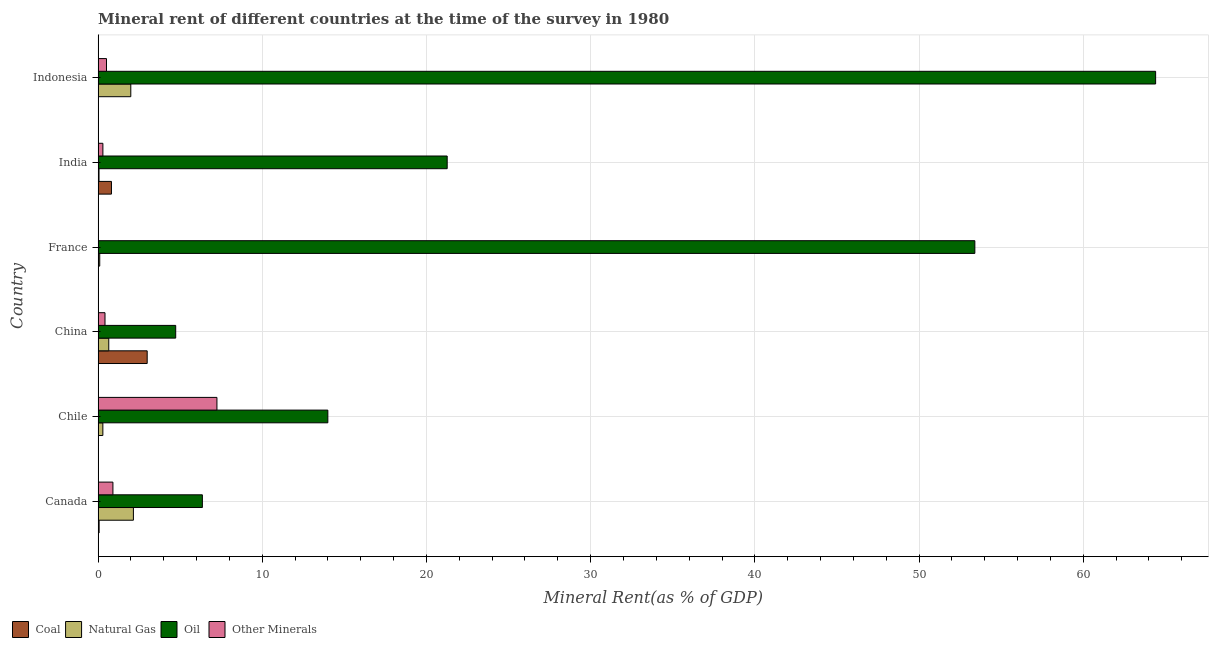How many different coloured bars are there?
Your answer should be very brief. 4. Are the number of bars per tick equal to the number of legend labels?
Offer a very short reply. Yes. Are the number of bars on each tick of the Y-axis equal?
Provide a short and direct response. Yes. What is the label of the 3rd group of bars from the top?
Give a very brief answer. France. In how many cases, is the number of bars for a given country not equal to the number of legend labels?
Your response must be concise. 0. What is the oil rent in Indonesia?
Your answer should be compact. 64.41. Across all countries, what is the maximum  rent of other minerals?
Your answer should be compact. 7.24. Across all countries, what is the minimum oil rent?
Offer a terse response. 4.73. In which country was the oil rent maximum?
Keep it short and to the point. Indonesia. What is the total coal rent in the graph?
Give a very brief answer. 3.89. What is the difference between the coal rent in France and that in Indonesia?
Provide a succinct answer. 0.01. What is the difference between the oil rent in China and the  rent of other minerals in Chile?
Offer a very short reply. -2.51. What is the average  rent of other minerals per country?
Offer a terse response. 1.56. What is the difference between the coal rent and  rent of other minerals in Indonesia?
Your answer should be very brief. -0.51. What is the ratio of the  rent of other minerals in China to that in France?
Your answer should be very brief. 27.3. Is the natural gas rent in Chile less than that in France?
Keep it short and to the point. No. What is the difference between the highest and the second highest oil rent?
Give a very brief answer. 11.01. What is the difference between the highest and the lowest  rent of other minerals?
Provide a short and direct response. 7.22. What does the 4th bar from the top in Indonesia represents?
Your response must be concise. Coal. What does the 3rd bar from the bottom in Canada represents?
Your answer should be very brief. Oil. Is it the case that in every country, the sum of the coal rent and natural gas rent is greater than the oil rent?
Make the answer very short. No. How many bars are there?
Keep it short and to the point. 24. Are all the bars in the graph horizontal?
Make the answer very short. Yes. How many countries are there in the graph?
Your answer should be compact. 6. Does the graph contain any zero values?
Your response must be concise. No. Does the graph contain grids?
Your response must be concise. Yes. How many legend labels are there?
Provide a short and direct response. 4. How are the legend labels stacked?
Your answer should be compact. Horizontal. What is the title of the graph?
Give a very brief answer. Mineral rent of different countries at the time of the survey in 1980. Does "Social Protection" appear as one of the legend labels in the graph?
Your answer should be very brief. No. What is the label or title of the X-axis?
Make the answer very short. Mineral Rent(as % of GDP). What is the label or title of the Y-axis?
Offer a terse response. Country. What is the Mineral Rent(as % of GDP) in Coal in Canada?
Offer a very short reply. 0.06. What is the Mineral Rent(as % of GDP) in Natural Gas in Canada?
Offer a terse response. 2.15. What is the Mineral Rent(as % of GDP) of Oil in Canada?
Your response must be concise. 6.35. What is the Mineral Rent(as % of GDP) of Other Minerals in Canada?
Offer a very short reply. 0.9. What is the Mineral Rent(as % of GDP) in Coal in Chile?
Provide a short and direct response. 0.02. What is the Mineral Rent(as % of GDP) of Natural Gas in Chile?
Offer a terse response. 0.29. What is the Mineral Rent(as % of GDP) in Oil in Chile?
Keep it short and to the point. 13.99. What is the Mineral Rent(as % of GDP) in Other Minerals in Chile?
Keep it short and to the point. 7.24. What is the Mineral Rent(as % of GDP) of Coal in China?
Ensure brevity in your answer.  2.99. What is the Mineral Rent(as % of GDP) in Natural Gas in China?
Your answer should be very brief. 0.65. What is the Mineral Rent(as % of GDP) of Oil in China?
Make the answer very short. 4.73. What is the Mineral Rent(as % of GDP) of Other Minerals in China?
Keep it short and to the point. 0.42. What is the Mineral Rent(as % of GDP) of Coal in France?
Your answer should be compact. 0.01. What is the Mineral Rent(as % of GDP) of Natural Gas in France?
Provide a succinct answer. 0.1. What is the Mineral Rent(as % of GDP) in Oil in France?
Offer a very short reply. 53.4. What is the Mineral Rent(as % of GDP) of Other Minerals in France?
Keep it short and to the point. 0.02. What is the Mineral Rent(as % of GDP) of Coal in India?
Provide a succinct answer. 0.81. What is the Mineral Rent(as % of GDP) of Natural Gas in India?
Your answer should be compact. 0.06. What is the Mineral Rent(as % of GDP) of Oil in India?
Offer a terse response. 21.26. What is the Mineral Rent(as % of GDP) of Other Minerals in India?
Provide a short and direct response. 0.29. What is the Mineral Rent(as % of GDP) in Coal in Indonesia?
Your answer should be very brief. 0. What is the Mineral Rent(as % of GDP) of Natural Gas in Indonesia?
Provide a short and direct response. 1.99. What is the Mineral Rent(as % of GDP) in Oil in Indonesia?
Make the answer very short. 64.41. What is the Mineral Rent(as % of GDP) in Other Minerals in Indonesia?
Keep it short and to the point. 0.51. Across all countries, what is the maximum Mineral Rent(as % of GDP) of Coal?
Your answer should be compact. 2.99. Across all countries, what is the maximum Mineral Rent(as % of GDP) in Natural Gas?
Your response must be concise. 2.15. Across all countries, what is the maximum Mineral Rent(as % of GDP) of Oil?
Your answer should be compact. 64.41. Across all countries, what is the maximum Mineral Rent(as % of GDP) in Other Minerals?
Ensure brevity in your answer.  7.24. Across all countries, what is the minimum Mineral Rent(as % of GDP) in Coal?
Provide a short and direct response. 0. Across all countries, what is the minimum Mineral Rent(as % of GDP) in Natural Gas?
Your answer should be compact. 0.06. Across all countries, what is the minimum Mineral Rent(as % of GDP) in Oil?
Your answer should be compact. 4.73. Across all countries, what is the minimum Mineral Rent(as % of GDP) in Other Minerals?
Provide a short and direct response. 0.02. What is the total Mineral Rent(as % of GDP) in Coal in the graph?
Keep it short and to the point. 3.89. What is the total Mineral Rent(as % of GDP) of Natural Gas in the graph?
Give a very brief answer. 5.23. What is the total Mineral Rent(as % of GDP) in Oil in the graph?
Provide a succinct answer. 164.14. What is the total Mineral Rent(as % of GDP) in Other Minerals in the graph?
Provide a short and direct response. 9.38. What is the difference between the Mineral Rent(as % of GDP) in Coal in Canada and that in Chile?
Your answer should be compact. 0.04. What is the difference between the Mineral Rent(as % of GDP) of Natural Gas in Canada and that in Chile?
Your answer should be very brief. 1.86. What is the difference between the Mineral Rent(as % of GDP) of Oil in Canada and that in Chile?
Offer a terse response. -7.64. What is the difference between the Mineral Rent(as % of GDP) in Other Minerals in Canada and that in Chile?
Your answer should be compact. -6.34. What is the difference between the Mineral Rent(as % of GDP) in Coal in Canada and that in China?
Ensure brevity in your answer.  -2.93. What is the difference between the Mineral Rent(as % of GDP) of Natural Gas in Canada and that in China?
Give a very brief answer. 1.5. What is the difference between the Mineral Rent(as % of GDP) in Oil in Canada and that in China?
Keep it short and to the point. 1.62. What is the difference between the Mineral Rent(as % of GDP) of Other Minerals in Canada and that in China?
Ensure brevity in your answer.  0.48. What is the difference between the Mineral Rent(as % of GDP) of Coal in Canada and that in France?
Keep it short and to the point. 0.05. What is the difference between the Mineral Rent(as % of GDP) in Natural Gas in Canada and that in France?
Provide a short and direct response. 2.05. What is the difference between the Mineral Rent(as % of GDP) of Oil in Canada and that in France?
Ensure brevity in your answer.  -47.05. What is the difference between the Mineral Rent(as % of GDP) of Other Minerals in Canada and that in France?
Offer a very short reply. 0.89. What is the difference between the Mineral Rent(as % of GDP) in Coal in Canada and that in India?
Your answer should be compact. -0.75. What is the difference between the Mineral Rent(as % of GDP) of Natural Gas in Canada and that in India?
Your response must be concise. 2.09. What is the difference between the Mineral Rent(as % of GDP) of Oil in Canada and that in India?
Ensure brevity in your answer.  -14.91. What is the difference between the Mineral Rent(as % of GDP) in Other Minerals in Canada and that in India?
Your answer should be very brief. 0.61. What is the difference between the Mineral Rent(as % of GDP) in Coal in Canada and that in Indonesia?
Ensure brevity in your answer.  0.06. What is the difference between the Mineral Rent(as % of GDP) in Natural Gas in Canada and that in Indonesia?
Ensure brevity in your answer.  0.16. What is the difference between the Mineral Rent(as % of GDP) in Oil in Canada and that in Indonesia?
Your response must be concise. -58.06. What is the difference between the Mineral Rent(as % of GDP) of Other Minerals in Canada and that in Indonesia?
Make the answer very short. 0.39. What is the difference between the Mineral Rent(as % of GDP) of Coal in Chile and that in China?
Make the answer very short. -2.97. What is the difference between the Mineral Rent(as % of GDP) of Natural Gas in Chile and that in China?
Your response must be concise. -0.36. What is the difference between the Mineral Rent(as % of GDP) in Oil in Chile and that in China?
Your answer should be compact. 9.27. What is the difference between the Mineral Rent(as % of GDP) of Other Minerals in Chile and that in China?
Offer a very short reply. 6.82. What is the difference between the Mineral Rent(as % of GDP) of Coal in Chile and that in France?
Your response must be concise. 0. What is the difference between the Mineral Rent(as % of GDP) in Natural Gas in Chile and that in France?
Make the answer very short. 0.19. What is the difference between the Mineral Rent(as % of GDP) of Oil in Chile and that in France?
Keep it short and to the point. -39.41. What is the difference between the Mineral Rent(as % of GDP) of Other Minerals in Chile and that in France?
Offer a very short reply. 7.22. What is the difference between the Mineral Rent(as % of GDP) of Coal in Chile and that in India?
Ensure brevity in your answer.  -0.8. What is the difference between the Mineral Rent(as % of GDP) in Natural Gas in Chile and that in India?
Provide a succinct answer. 0.23. What is the difference between the Mineral Rent(as % of GDP) of Oil in Chile and that in India?
Provide a succinct answer. -7.27. What is the difference between the Mineral Rent(as % of GDP) of Other Minerals in Chile and that in India?
Keep it short and to the point. 6.95. What is the difference between the Mineral Rent(as % of GDP) of Coal in Chile and that in Indonesia?
Make the answer very short. 0.01. What is the difference between the Mineral Rent(as % of GDP) of Natural Gas in Chile and that in Indonesia?
Your answer should be compact. -1.7. What is the difference between the Mineral Rent(as % of GDP) in Oil in Chile and that in Indonesia?
Give a very brief answer. -50.42. What is the difference between the Mineral Rent(as % of GDP) in Other Minerals in Chile and that in Indonesia?
Provide a succinct answer. 6.73. What is the difference between the Mineral Rent(as % of GDP) of Coal in China and that in France?
Provide a succinct answer. 2.98. What is the difference between the Mineral Rent(as % of GDP) in Natural Gas in China and that in France?
Your answer should be compact. 0.55. What is the difference between the Mineral Rent(as % of GDP) of Oil in China and that in France?
Offer a terse response. -48.67. What is the difference between the Mineral Rent(as % of GDP) in Other Minerals in China and that in France?
Provide a short and direct response. 0.4. What is the difference between the Mineral Rent(as % of GDP) in Coal in China and that in India?
Your answer should be compact. 2.18. What is the difference between the Mineral Rent(as % of GDP) of Natural Gas in China and that in India?
Provide a succinct answer. 0.59. What is the difference between the Mineral Rent(as % of GDP) in Oil in China and that in India?
Offer a terse response. -16.54. What is the difference between the Mineral Rent(as % of GDP) in Other Minerals in China and that in India?
Give a very brief answer. 0.13. What is the difference between the Mineral Rent(as % of GDP) of Coal in China and that in Indonesia?
Your response must be concise. 2.98. What is the difference between the Mineral Rent(as % of GDP) in Natural Gas in China and that in Indonesia?
Your answer should be very brief. -1.34. What is the difference between the Mineral Rent(as % of GDP) of Oil in China and that in Indonesia?
Give a very brief answer. -59.69. What is the difference between the Mineral Rent(as % of GDP) in Other Minerals in China and that in Indonesia?
Keep it short and to the point. -0.09. What is the difference between the Mineral Rent(as % of GDP) in Coal in France and that in India?
Make the answer very short. -0.8. What is the difference between the Mineral Rent(as % of GDP) of Natural Gas in France and that in India?
Your answer should be very brief. 0.04. What is the difference between the Mineral Rent(as % of GDP) in Oil in France and that in India?
Offer a very short reply. 32.14. What is the difference between the Mineral Rent(as % of GDP) in Other Minerals in France and that in India?
Ensure brevity in your answer.  -0.28. What is the difference between the Mineral Rent(as % of GDP) of Coal in France and that in Indonesia?
Offer a very short reply. 0.01. What is the difference between the Mineral Rent(as % of GDP) in Natural Gas in France and that in Indonesia?
Ensure brevity in your answer.  -1.89. What is the difference between the Mineral Rent(as % of GDP) in Oil in France and that in Indonesia?
Your answer should be very brief. -11.01. What is the difference between the Mineral Rent(as % of GDP) in Other Minerals in France and that in Indonesia?
Provide a succinct answer. -0.5. What is the difference between the Mineral Rent(as % of GDP) of Coal in India and that in Indonesia?
Keep it short and to the point. 0.81. What is the difference between the Mineral Rent(as % of GDP) of Natural Gas in India and that in Indonesia?
Give a very brief answer. -1.94. What is the difference between the Mineral Rent(as % of GDP) in Oil in India and that in Indonesia?
Provide a succinct answer. -43.15. What is the difference between the Mineral Rent(as % of GDP) in Other Minerals in India and that in Indonesia?
Your response must be concise. -0.22. What is the difference between the Mineral Rent(as % of GDP) of Coal in Canada and the Mineral Rent(as % of GDP) of Natural Gas in Chile?
Make the answer very short. -0.23. What is the difference between the Mineral Rent(as % of GDP) in Coal in Canada and the Mineral Rent(as % of GDP) in Oil in Chile?
Your answer should be compact. -13.93. What is the difference between the Mineral Rent(as % of GDP) of Coal in Canada and the Mineral Rent(as % of GDP) of Other Minerals in Chile?
Provide a short and direct response. -7.18. What is the difference between the Mineral Rent(as % of GDP) in Natural Gas in Canada and the Mineral Rent(as % of GDP) in Oil in Chile?
Your answer should be compact. -11.84. What is the difference between the Mineral Rent(as % of GDP) in Natural Gas in Canada and the Mineral Rent(as % of GDP) in Other Minerals in Chile?
Ensure brevity in your answer.  -5.09. What is the difference between the Mineral Rent(as % of GDP) in Oil in Canada and the Mineral Rent(as % of GDP) in Other Minerals in Chile?
Make the answer very short. -0.89. What is the difference between the Mineral Rent(as % of GDP) of Coal in Canada and the Mineral Rent(as % of GDP) of Natural Gas in China?
Give a very brief answer. -0.59. What is the difference between the Mineral Rent(as % of GDP) in Coal in Canada and the Mineral Rent(as % of GDP) in Oil in China?
Your response must be concise. -4.66. What is the difference between the Mineral Rent(as % of GDP) of Coal in Canada and the Mineral Rent(as % of GDP) of Other Minerals in China?
Offer a terse response. -0.36. What is the difference between the Mineral Rent(as % of GDP) in Natural Gas in Canada and the Mineral Rent(as % of GDP) in Oil in China?
Offer a very short reply. -2.58. What is the difference between the Mineral Rent(as % of GDP) in Natural Gas in Canada and the Mineral Rent(as % of GDP) in Other Minerals in China?
Give a very brief answer. 1.73. What is the difference between the Mineral Rent(as % of GDP) of Oil in Canada and the Mineral Rent(as % of GDP) of Other Minerals in China?
Your answer should be compact. 5.93. What is the difference between the Mineral Rent(as % of GDP) of Coal in Canada and the Mineral Rent(as % of GDP) of Natural Gas in France?
Your response must be concise. -0.04. What is the difference between the Mineral Rent(as % of GDP) in Coal in Canada and the Mineral Rent(as % of GDP) in Oil in France?
Offer a very short reply. -53.34. What is the difference between the Mineral Rent(as % of GDP) of Coal in Canada and the Mineral Rent(as % of GDP) of Other Minerals in France?
Ensure brevity in your answer.  0.05. What is the difference between the Mineral Rent(as % of GDP) of Natural Gas in Canada and the Mineral Rent(as % of GDP) of Oil in France?
Offer a terse response. -51.25. What is the difference between the Mineral Rent(as % of GDP) of Natural Gas in Canada and the Mineral Rent(as % of GDP) of Other Minerals in France?
Provide a short and direct response. 2.13. What is the difference between the Mineral Rent(as % of GDP) of Oil in Canada and the Mineral Rent(as % of GDP) of Other Minerals in France?
Your response must be concise. 6.33. What is the difference between the Mineral Rent(as % of GDP) of Coal in Canada and the Mineral Rent(as % of GDP) of Natural Gas in India?
Offer a very short reply. 0.01. What is the difference between the Mineral Rent(as % of GDP) in Coal in Canada and the Mineral Rent(as % of GDP) in Oil in India?
Offer a very short reply. -21.2. What is the difference between the Mineral Rent(as % of GDP) of Coal in Canada and the Mineral Rent(as % of GDP) of Other Minerals in India?
Make the answer very short. -0.23. What is the difference between the Mineral Rent(as % of GDP) of Natural Gas in Canada and the Mineral Rent(as % of GDP) of Oil in India?
Provide a succinct answer. -19.11. What is the difference between the Mineral Rent(as % of GDP) in Natural Gas in Canada and the Mineral Rent(as % of GDP) in Other Minerals in India?
Your response must be concise. 1.86. What is the difference between the Mineral Rent(as % of GDP) in Oil in Canada and the Mineral Rent(as % of GDP) in Other Minerals in India?
Your answer should be compact. 6.06. What is the difference between the Mineral Rent(as % of GDP) of Coal in Canada and the Mineral Rent(as % of GDP) of Natural Gas in Indonesia?
Make the answer very short. -1.93. What is the difference between the Mineral Rent(as % of GDP) of Coal in Canada and the Mineral Rent(as % of GDP) of Oil in Indonesia?
Give a very brief answer. -64.35. What is the difference between the Mineral Rent(as % of GDP) in Coal in Canada and the Mineral Rent(as % of GDP) in Other Minerals in Indonesia?
Provide a short and direct response. -0.45. What is the difference between the Mineral Rent(as % of GDP) of Natural Gas in Canada and the Mineral Rent(as % of GDP) of Oil in Indonesia?
Offer a very short reply. -62.26. What is the difference between the Mineral Rent(as % of GDP) of Natural Gas in Canada and the Mineral Rent(as % of GDP) of Other Minerals in Indonesia?
Ensure brevity in your answer.  1.64. What is the difference between the Mineral Rent(as % of GDP) in Oil in Canada and the Mineral Rent(as % of GDP) in Other Minerals in Indonesia?
Offer a very short reply. 5.84. What is the difference between the Mineral Rent(as % of GDP) in Coal in Chile and the Mineral Rent(as % of GDP) in Natural Gas in China?
Ensure brevity in your answer.  -0.63. What is the difference between the Mineral Rent(as % of GDP) of Coal in Chile and the Mineral Rent(as % of GDP) of Oil in China?
Give a very brief answer. -4.71. What is the difference between the Mineral Rent(as % of GDP) of Coal in Chile and the Mineral Rent(as % of GDP) of Other Minerals in China?
Your answer should be compact. -0.4. What is the difference between the Mineral Rent(as % of GDP) of Natural Gas in Chile and the Mineral Rent(as % of GDP) of Oil in China?
Offer a terse response. -4.44. What is the difference between the Mineral Rent(as % of GDP) of Natural Gas in Chile and the Mineral Rent(as % of GDP) of Other Minerals in China?
Provide a succinct answer. -0.13. What is the difference between the Mineral Rent(as % of GDP) in Oil in Chile and the Mineral Rent(as % of GDP) in Other Minerals in China?
Your response must be concise. 13.57. What is the difference between the Mineral Rent(as % of GDP) in Coal in Chile and the Mineral Rent(as % of GDP) in Natural Gas in France?
Your answer should be very brief. -0.08. What is the difference between the Mineral Rent(as % of GDP) of Coal in Chile and the Mineral Rent(as % of GDP) of Oil in France?
Give a very brief answer. -53.38. What is the difference between the Mineral Rent(as % of GDP) of Coal in Chile and the Mineral Rent(as % of GDP) of Other Minerals in France?
Your response must be concise. 0. What is the difference between the Mineral Rent(as % of GDP) of Natural Gas in Chile and the Mineral Rent(as % of GDP) of Oil in France?
Provide a succinct answer. -53.11. What is the difference between the Mineral Rent(as % of GDP) in Natural Gas in Chile and the Mineral Rent(as % of GDP) in Other Minerals in France?
Ensure brevity in your answer.  0.27. What is the difference between the Mineral Rent(as % of GDP) of Oil in Chile and the Mineral Rent(as % of GDP) of Other Minerals in France?
Provide a short and direct response. 13.98. What is the difference between the Mineral Rent(as % of GDP) of Coal in Chile and the Mineral Rent(as % of GDP) of Natural Gas in India?
Your answer should be compact. -0.04. What is the difference between the Mineral Rent(as % of GDP) in Coal in Chile and the Mineral Rent(as % of GDP) in Oil in India?
Give a very brief answer. -21.24. What is the difference between the Mineral Rent(as % of GDP) in Coal in Chile and the Mineral Rent(as % of GDP) in Other Minerals in India?
Give a very brief answer. -0.27. What is the difference between the Mineral Rent(as % of GDP) in Natural Gas in Chile and the Mineral Rent(as % of GDP) in Oil in India?
Provide a short and direct response. -20.97. What is the difference between the Mineral Rent(as % of GDP) of Natural Gas in Chile and the Mineral Rent(as % of GDP) of Other Minerals in India?
Provide a succinct answer. -0. What is the difference between the Mineral Rent(as % of GDP) in Oil in Chile and the Mineral Rent(as % of GDP) in Other Minerals in India?
Give a very brief answer. 13.7. What is the difference between the Mineral Rent(as % of GDP) in Coal in Chile and the Mineral Rent(as % of GDP) in Natural Gas in Indonesia?
Ensure brevity in your answer.  -1.97. What is the difference between the Mineral Rent(as % of GDP) in Coal in Chile and the Mineral Rent(as % of GDP) in Oil in Indonesia?
Your answer should be compact. -64.39. What is the difference between the Mineral Rent(as % of GDP) of Coal in Chile and the Mineral Rent(as % of GDP) of Other Minerals in Indonesia?
Your answer should be compact. -0.49. What is the difference between the Mineral Rent(as % of GDP) in Natural Gas in Chile and the Mineral Rent(as % of GDP) in Oil in Indonesia?
Your answer should be compact. -64.12. What is the difference between the Mineral Rent(as % of GDP) in Natural Gas in Chile and the Mineral Rent(as % of GDP) in Other Minerals in Indonesia?
Ensure brevity in your answer.  -0.22. What is the difference between the Mineral Rent(as % of GDP) of Oil in Chile and the Mineral Rent(as % of GDP) of Other Minerals in Indonesia?
Your answer should be very brief. 13.48. What is the difference between the Mineral Rent(as % of GDP) of Coal in China and the Mineral Rent(as % of GDP) of Natural Gas in France?
Offer a terse response. 2.89. What is the difference between the Mineral Rent(as % of GDP) of Coal in China and the Mineral Rent(as % of GDP) of Oil in France?
Your answer should be very brief. -50.41. What is the difference between the Mineral Rent(as % of GDP) of Coal in China and the Mineral Rent(as % of GDP) of Other Minerals in France?
Provide a succinct answer. 2.97. What is the difference between the Mineral Rent(as % of GDP) in Natural Gas in China and the Mineral Rent(as % of GDP) in Oil in France?
Keep it short and to the point. -52.75. What is the difference between the Mineral Rent(as % of GDP) in Natural Gas in China and the Mineral Rent(as % of GDP) in Other Minerals in France?
Offer a terse response. 0.63. What is the difference between the Mineral Rent(as % of GDP) of Oil in China and the Mineral Rent(as % of GDP) of Other Minerals in France?
Offer a very short reply. 4.71. What is the difference between the Mineral Rent(as % of GDP) in Coal in China and the Mineral Rent(as % of GDP) in Natural Gas in India?
Offer a terse response. 2.93. What is the difference between the Mineral Rent(as % of GDP) of Coal in China and the Mineral Rent(as % of GDP) of Oil in India?
Keep it short and to the point. -18.27. What is the difference between the Mineral Rent(as % of GDP) in Coal in China and the Mineral Rent(as % of GDP) in Other Minerals in India?
Keep it short and to the point. 2.7. What is the difference between the Mineral Rent(as % of GDP) in Natural Gas in China and the Mineral Rent(as % of GDP) in Oil in India?
Offer a very short reply. -20.61. What is the difference between the Mineral Rent(as % of GDP) of Natural Gas in China and the Mineral Rent(as % of GDP) of Other Minerals in India?
Your answer should be very brief. 0.36. What is the difference between the Mineral Rent(as % of GDP) in Oil in China and the Mineral Rent(as % of GDP) in Other Minerals in India?
Make the answer very short. 4.43. What is the difference between the Mineral Rent(as % of GDP) of Coal in China and the Mineral Rent(as % of GDP) of Oil in Indonesia?
Provide a short and direct response. -61.42. What is the difference between the Mineral Rent(as % of GDP) of Coal in China and the Mineral Rent(as % of GDP) of Other Minerals in Indonesia?
Give a very brief answer. 2.48. What is the difference between the Mineral Rent(as % of GDP) in Natural Gas in China and the Mineral Rent(as % of GDP) in Oil in Indonesia?
Your answer should be very brief. -63.76. What is the difference between the Mineral Rent(as % of GDP) of Natural Gas in China and the Mineral Rent(as % of GDP) of Other Minerals in Indonesia?
Your response must be concise. 0.14. What is the difference between the Mineral Rent(as % of GDP) of Oil in China and the Mineral Rent(as % of GDP) of Other Minerals in Indonesia?
Give a very brief answer. 4.21. What is the difference between the Mineral Rent(as % of GDP) of Coal in France and the Mineral Rent(as % of GDP) of Natural Gas in India?
Ensure brevity in your answer.  -0.04. What is the difference between the Mineral Rent(as % of GDP) of Coal in France and the Mineral Rent(as % of GDP) of Oil in India?
Provide a short and direct response. -21.25. What is the difference between the Mineral Rent(as % of GDP) in Coal in France and the Mineral Rent(as % of GDP) in Other Minerals in India?
Give a very brief answer. -0.28. What is the difference between the Mineral Rent(as % of GDP) of Natural Gas in France and the Mineral Rent(as % of GDP) of Oil in India?
Make the answer very short. -21.16. What is the difference between the Mineral Rent(as % of GDP) in Natural Gas in France and the Mineral Rent(as % of GDP) in Other Minerals in India?
Provide a short and direct response. -0.19. What is the difference between the Mineral Rent(as % of GDP) of Oil in France and the Mineral Rent(as % of GDP) of Other Minerals in India?
Your response must be concise. 53.11. What is the difference between the Mineral Rent(as % of GDP) in Coal in France and the Mineral Rent(as % of GDP) in Natural Gas in Indonesia?
Give a very brief answer. -1.98. What is the difference between the Mineral Rent(as % of GDP) of Coal in France and the Mineral Rent(as % of GDP) of Oil in Indonesia?
Make the answer very short. -64.4. What is the difference between the Mineral Rent(as % of GDP) in Coal in France and the Mineral Rent(as % of GDP) in Other Minerals in Indonesia?
Provide a succinct answer. -0.5. What is the difference between the Mineral Rent(as % of GDP) of Natural Gas in France and the Mineral Rent(as % of GDP) of Oil in Indonesia?
Your answer should be very brief. -64.31. What is the difference between the Mineral Rent(as % of GDP) of Natural Gas in France and the Mineral Rent(as % of GDP) of Other Minerals in Indonesia?
Your answer should be very brief. -0.41. What is the difference between the Mineral Rent(as % of GDP) of Oil in France and the Mineral Rent(as % of GDP) of Other Minerals in Indonesia?
Provide a short and direct response. 52.89. What is the difference between the Mineral Rent(as % of GDP) in Coal in India and the Mineral Rent(as % of GDP) in Natural Gas in Indonesia?
Give a very brief answer. -1.18. What is the difference between the Mineral Rent(as % of GDP) in Coal in India and the Mineral Rent(as % of GDP) in Oil in Indonesia?
Your answer should be very brief. -63.6. What is the difference between the Mineral Rent(as % of GDP) of Coal in India and the Mineral Rent(as % of GDP) of Other Minerals in Indonesia?
Your response must be concise. 0.3. What is the difference between the Mineral Rent(as % of GDP) in Natural Gas in India and the Mineral Rent(as % of GDP) in Oil in Indonesia?
Ensure brevity in your answer.  -64.35. What is the difference between the Mineral Rent(as % of GDP) of Natural Gas in India and the Mineral Rent(as % of GDP) of Other Minerals in Indonesia?
Make the answer very short. -0.46. What is the difference between the Mineral Rent(as % of GDP) in Oil in India and the Mineral Rent(as % of GDP) in Other Minerals in Indonesia?
Keep it short and to the point. 20.75. What is the average Mineral Rent(as % of GDP) of Coal per country?
Provide a succinct answer. 0.65. What is the average Mineral Rent(as % of GDP) in Natural Gas per country?
Provide a short and direct response. 0.87. What is the average Mineral Rent(as % of GDP) in Oil per country?
Provide a short and direct response. 27.36. What is the average Mineral Rent(as % of GDP) in Other Minerals per country?
Your response must be concise. 1.56. What is the difference between the Mineral Rent(as % of GDP) of Coal and Mineral Rent(as % of GDP) of Natural Gas in Canada?
Offer a terse response. -2.09. What is the difference between the Mineral Rent(as % of GDP) in Coal and Mineral Rent(as % of GDP) in Oil in Canada?
Offer a terse response. -6.29. What is the difference between the Mineral Rent(as % of GDP) in Coal and Mineral Rent(as % of GDP) in Other Minerals in Canada?
Your answer should be very brief. -0.84. What is the difference between the Mineral Rent(as % of GDP) in Natural Gas and Mineral Rent(as % of GDP) in Oil in Canada?
Keep it short and to the point. -4.2. What is the difference between the Mineral Rent(as % of GDP) in Natural Gas and Mineral Rent(as % of GDP) in Other Minerals in Canada?
Provide a succinct answer. 1.25. What is the difference between the Mineral Rent(as % of GDP) in Oil and Mineral Rent(as % of GDP) in Other Minerals in Canada?
Give a very brief answer. 5.45. What is the difference between the Mineral Rent(as % of GDP) in Coal and Mineral Rent(as % of GDP) in Natural Gas in Chile?
Provide a succinct answer. -0.27. What is the difference between the Mineral Rent(as % of GDP) in Coal and Mineral Rent(as % of GDP) in Oil in Chile?
Provide a short and direct response. -13.98. What is the difference between the Mineral Rent(as % of GDP) of Coal and Mineral Rent(as % of GDP) of Other Minerals in Chile?
Provide a succinct answer. -7.22. What is the difference between the Mineral Rent(as % of GDP) of Natural Gas and Mineral Rent(as % of GDP) of Oil in Chile?
Make the answer very short. -13.7. What is the difference between the Mineral Rent(as % of GDP) in Natural Gas and Mineral Rent(as % of GDP) in Other Minerals in Chile?
Your answer should be very brief. -6.95. What is the difference between the Mineral Rent(as % of GDP) of Oil and Mineral Rent(as % of GDP) of Other Minerals in Chile?
Your answer should be compact. 6.75. What is the difference between the Mineral Rent(as % of GDP) of Coal and Mineral Rent(as % of GDP) of Natural Gas in China?
Your answer should be compact. 2.34. What is the difference between the Mineral Rent(as % of GDP) of Coal and Mineral Rent(as % of GDP) of Oil in China?
Provide a succinct answer. -1.74. What is the difference between the Mineral Rent(as % of GDP) in Coal and Mineral Rent(as % of GDP) in Other Minerals in China?
Keep it short and to the point. 2.57. What is the difference between the Mineral Rent(as % of GDP) in Natural Gas and Mineral Rent(as % of GDP) in Oil in China?
Ensure brevity in your answer.  -4.08. What is the difference between the Mineral Rent(as % of GDP) of Natural Gas and Mineral Rent(as % of GDP) of Other Minerals in China?
Offer a very short reply. 0.23. What is the difference between the Mineral Rent(as % of GDP) in Oil and Mineral Rent(as % of GDP) in Other Minerals in China?
Offer a very short reply. 4.31. What is the difference between the Mineral Rent(as % of GDP) of Coal and Mineral Rent(as % of GDP) of Natural Gas in France?
Offer a terse response. -0.09. What is the difference between the Mineral Rent(as % of GDP) of Coal and Mineral Rent(as % of GDP) of Oil in France?
Offer a very short reply. -53.39. What is the difference between the Mineral Rent(as % of GDP) of Coal and Mineral Rent(as % of GDP) of Other Minerals in France?
Your answer should be very brief. -0. What is the difference between the Mineral Rent(as % of GDP) in Natural Gas and Mineral Rent(as % of GDP) in Oil in France?
Your answer should be compact. -53.3. What is the difference between the Mineral Rent(as % of GDP) in Natural Gas and Mineral Rent(as % of GDP) in Other Minerals in France?
Make the answer very short. 0.08. What is the difference between the Mineral Rent(as % of GDP) of Oil and Mineral Rent(as % of GDP) of Other Minerals in France?
Make the answer very short. 53.38. What is the difference between the Mineral Rent(as % of GDP) in Coal and Mineral Rent(as % of GDP) in Natural Gas in India?
Offer a terse response. 0.76. What is the difference between the Mineral Rent(as % of GDP) in Coal and Mineral Rent(as % of GDP) in Oil in India?
Give a very brief answer. -20.45. What is the difference between the Mineral Rent(as % of GDP) in Coal and Mineral Rent(as % of GDP) in Other Minerals in India?
Your answer should be very brief. 0.52. What is the difference between the Mineral Rent(as % of GDP) in Natural Gas and Mineral Rent(as % of GDP) in Oil in India?
Your answer should be very brief. -21.21. What is the difference between the Mineral Rent(as % of GDP) of Natural Gas and Mineral Rent(as % of GDP) of Other Minerals in India?
Your answer should be very brief. -0.24. What is the difference between the Mineral Rent(as % of GDP) of Oil and Mineral Rent(as % of GDP) of Other Minerals in India?
Provide a short and direct response. 20.97. What is the difference between the Mineral Rent(as % of GDP) of Coal and Mineral Rent(as % of GDP) of Natural Gas in Indonesia?
Provide a short and direct response. -1.99. What is the difference between the Mineral Rent(as % of GDP) in Coal and Mineral Rent(as % of GDP) in Oil in Indonesia?
Offer a very short reply. -64.41. What is the difference between the Mineral Rent(as % of GDP) in Coal and Mineral Rent(as % of GDP) in Other Minerals in Indonesia?
Your answer should be compact. -0.51. What is the difference between the Mineral Rent(as % of GDP) of Natural Gas and Mineral Rent(as % of GDP) of Oil in Indonesia?
Offer a very short reply. -62.42. What is the difference between the Mineral Rent(as % of GDP) in Natural Gas and Mineral Rent(as % of GDP) in Other Minerals in Indonesia?
Offer a very short reply. 1.48. What is the difference between the Mineral Rent(as % of GDP) in Oil and Mineral Rent(as % of GDP) in Other Minerals in Indonesia?
Give a very brief answer. 63.9. What is the ratio of the Mineral Rent(as % of GDP) of Coal in Canada to that in Chile?
Your response must be concise. 3.72. What is the ratio of the Mineral Rent(as % of GDP) in Natural Gas in Canada to that in Chile?
Give a very brief answer. 7.43. What is the ratio of the Mineral Rent(as % of GDP) of Oil in Canada to that in Chile?
Your response must be concise. 0.45. What is the ratio of the Mineral Rent(as % of GDP) in Other Minerals in Canada to that in Chile?
Your answer should be compact. 0.12. What is the ratio of the Mineral Rent(as % of GDP) in Coal in Canada to that in China?
Offer a terse response. 0.02. What is the ratio of the Mineral Rent(as % of GDP) in Natural Gas in Canada to that in China?
Make the answer very short. 3.31. What is the ratio of the Mineral Rent(as % of GDP) in Oil in Canada to that in China?
Ensure brevity in your answer.  1.34. What is the ratio of the Mineral Rent(as % of GDP) of Other Minerals in Canada to that in China?
Make the answer very short. 2.15. What is the ratio of the Mineral Rent(as % of GDP) of Coal in Canada to that in France?
Offer a terse response. 4.89. What is the ratio of the Mineral Rent(as % of GDP) of Natural Gas in Canada to that in France?
Make the answer very short. 21.8. What is the ratio of the Mineral Rent(as % of GDP) of Oil in Canada to that in France?
Ensure brevity in your answer.  0.12. What is the ratio of the Mineral Rent(as % of GDP) in Other Minerals in Canada to that in France?
Provide a short and direct response. 58.68. What is the ratio of the Mineral Rent(as % of GDP) of Coal in Canada to that in India?
Give a very brief answer. 0.08. What is the ratio of the Mineral Rent(as % of GDP) in Natural Gas in Canada to that in India?
Ensure brevity in your answer.  38.5. What is the ratio of the Mineral Rent(as % of GDP) in Oil in Canada to that in India?
Provide a succinct answer. 0.3. What is the ratio of the Mineral Rent(as % of GDP) of Other Minerals in Canada to that in India?
Offer a terse response. 3.1. What is the ratio of the Mineral Rent(as % of GDP) in Coal in Canada to that in Indonesia?
Give a very brief answer. 16.78. What is the ratio of the Mineral Rent(as % of GDP) in Natural Gas in Canada to that in Indonesia?
Offer a very short reply. 1.08. What is the ratio of the Mineral Rent(as % of GDP) of Oil in Canada to that in Indonesia?
Ensure brevity in your answer.  0.1. What is the ratio of the Mineral Rent(as % of GDP) of Other Minerals in Canada to that in Indonesia?
Offer a terse response. 1.76. What is the ratio of the Mineral Rent(as % of GDP) of Coal in Chile to that in China?
Provide a succinct answer. 0.01. What is the ratio of the Mineral Rent(as % of GDP) in Natural Gas in Chile to that in China?
Your answer should be compact. 0.45. What is the ratio of the Mineral Rent(as % of GDP) in Oil in Chile to that in China?
Provide a succinct answer. 2.96. What is the ratio of the Mineral Rent(as % of GDP) of Other Minerals in Chile to that in China?
Make the answer very short. 17.26. What is the ratio of the Mineral Rent(as % of GDP) in Coal in Chile to that in France?
Provide a succinct answer. 1.31. What is the ratio of the Mineral Rent(as % of GDP) of Natural Gas in Chile to that in France?
Ensure brevity in your answer.  2.93. What is the ratio of the Mineral Rent(as % of GDP) in Oil in Chile to that in France?
Your response must be concise. 0.26. What is the ratio of the Mineral Rent(as % of GDP) in Other Minerals in Chile to that in France?
Offer a very short reply. 471.11. What is the ratio of the Mineral Rent(as % of GDP) in Coal in Chile to that in India?
Your answer should be compact. 0.02. What is the ratio of the Mineral Rent(as % of GDP) of Natural Gas in Chile to that in India?
Offer a terse response. 5.18. What is the ratio of the Mineral Rent(as % of GDP) of Oil in Chile to that in India?
Provide a short and direct response. 0.66. What is the ratio of the Mineral Rent(as % of GDP) in Other Minerals in Chile to that in India?
Provide a succinct answer. 24.87. What is the ratio of the Mineral Rent(as % of GDP) of Coal in Chile to that in Indonesia?
Ensure brevity in your answer.  4.51. What is the ratio of the Mineral Rent(as % of GDP) of Natural Gas in Chile to that in Indonesia?
Make the answer very short. 0.15. What is the ratio of the Mineral Rent(as % of GDP) of Oil in Chile to that in Indonesia?
Offer a very short reply. 0.22. What is the ratio of the Mineral Rent(as % of GDP) in Other Minerals in Chile to that in Indonesia?
Give a very brief answer. 14.17. What is the ratio of the Mineral Rent(as % of GDP) in Coal in China to that in France?
Give a very brief answer. 238.24. What is the ratio of the Mineral Rent(as % of GDP) in Natural Gas in China to that in France?
Provide a short and direct response. 6.58. What is the ratio of the Mineral Rent(as % of GDP) of Oil in China to that in France?
Your answer should be very brief. 0.09. What is the ratio of the Mineral Rent(as % of GDP) of Other Minerals in China to that in France?
Your answer should be compact. 27.3. What is the ratio of the Mineral Rent(as % of GDP) in Coal in China to that in India?
Give a very brief answer. 3.68. What is the ratio of the Mineral Rent(as % of GDP) in Natural Gas in China to that in India?
Give a very brief answer. 11.62. What is the ratio of the Mineral Rent(as % of GDP) of Oil in China to that in India?
Give a very brief answer. 0.22. What is the ratio of the Mineral Rent(as % of GDP) in Other Minerals in China to that in India?
Offer a very short reply. 1.44. What is the ratio of the Mineral Rent(as % of GDP) in Coal in China to that in Indonesia?
Offer a very short reply. 818.4. What is the ratio of the Mineral Rent(as % of GDP) of Natural Gas in China to that in Indonesia?
Offer a very short reply. 0.33. What is the ratio of the Mineral Rent(as % of GDP) of Oil in China to that in Indonesia?
Give a very brief answer. 0.07. What is the ratio of the Mineral Rent(as % of GDP) of Other Minerals in China to that in Indonesia?
Make the answer very short. 0.82. What is the ratio of the Mineral Rent(as % of GDP) of Coal in France to that in India?
Provide a succinct answer. 0.02. What is the ratio of the Mineral Rent(as % of GDP) of Natural Gas in France to that in India?
Your answer should be compact. 1.77. What is the ratio of the Mineral Rent(as % of GDP) in Oil in France to that in India?
Give a very brief answer. 2.51. What is the ratio of the Mineral Rent(as % of GDP) in Other Minerals in France to that in India?
Provide a succinct answer. 0.05. What is the ratio of the Mineral Rent(as % of GDP) of Coal in France to that in Indonesia?
Ensure brevity in your answer.  3.44. What is the ratio of the Mineral Rent(as % of GDP) of Natural Gas in France to that in Indonesia?
Your answer should be very brief. 0.05. What is the ratio of the Mineral Rent(as % of GDP) of Oil in France to that in Indonesia?
Make the answer very short. 0.83. What is the ratio of the Mineral Rent(as % of GDP) of Other Minerals in France to that in Indonesia?
Keep it short and to the point. 0.03. What is the ratio of the Mineral Rent(as % of GDP) in Coal in India to that in Indonesia?
Provide a short and direct response. 222.43. What is the ratio of the Mineral Rent(as % of GDP) in Natural Gas in India to that in Indonesia?
Give a very brief answer. 0.03. What is the ratio of the Mineral Rent(as % of GDP) of Oil in India to that in Indonesia?
Ensure brevity in your answer.  0.33. What is the ratio of the Mineral Rent(as % of GDP) in Other Minerals in India to that in Indonesia?
Provide a succinct answer. 0.57. What is the difference between the highest and the second highest Mineral Rent(as % of GDP) of Coal?
Your answer should be very brief. 2.18. What is the difference between the highest and the second highest Mineral Rent(as % of GDP) of Natural Gas?
Give a very brief answer. 0.16. What is the difference between the highest and the second highest Mineral Rent(as % of GDP) of Oil?
Provide a succinct answer. 11.01. What is the difference between the highest and the second highest Mineral Rent(as % of GDP) of Other Minerals?
Your answer should be very brief. 6.34. What is the difference between the highest and the lowest Mineral Rent(as % of GDP) of Coal?
Provide a short and direct response. 2.98. What is the difference between the highest and the lowest Mineral Rent(as % of GDP) in Natural Gas?
Your response must be concise. 2.09. What is the difference between the highest and the lowest Mineral Rent(as % of GDP) of Oil?
Offer a very short reply. 59.69. What is the difference between the highest and the lowest Mineral Rent(as % of GDP) of Other Minerals?
Provide a short and direct response. 7.22. 